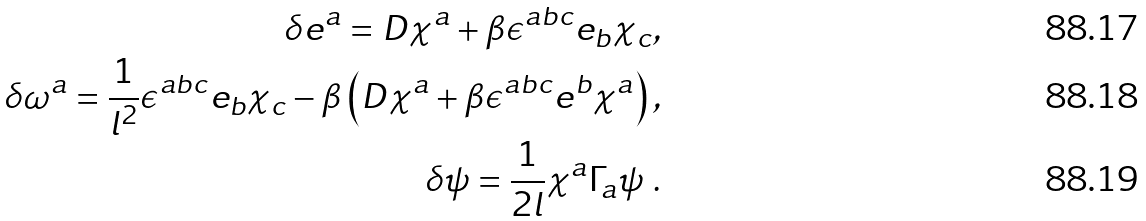<formula> <loc_0><loc_0><loc_500><loc_500>\delta e ^ { a } = D \chi ^ { a } + \beta \epsilon ^ { a b c } e _ { b } \chi _ { c } , \\ \delta \omega ^ { a } = \frac { 1 } { l ^ { 2 } } \epsilon ^ { a b c } e _ { b } \chi _ { c } - \beta \left ( D \chi ^ { a } + \beta \epsilon ^ { a b c } e ^ { b } \chi ^ { a } \right ) , \\ \delta \psi = \frac { 1 } { 2 l } \chi ^ { a } \Gamma _ { a } \psi \ .</formula> 